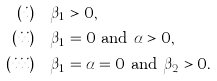Convert formula to latex. <formula><loc_0><loc_0><loc_500><loc_500>( i ) & \quad \beta _ { 1 } > 0 , \\ ( i i ) & \quad \beta _ { 1 } = 0 \text { and } \alpha > 0 , \\ ( i i i ) & \quad \beta _ { 1 } = \alpha = 0 \text { and } \beta _ { 2 } > 0 .</formula> 